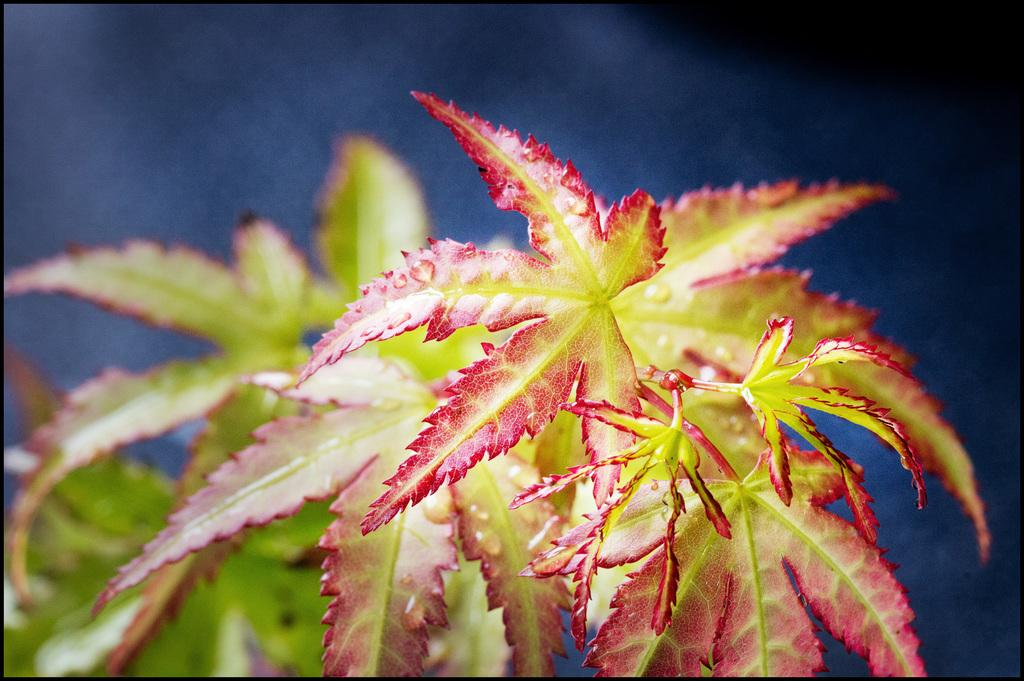What type of vegetation can be seen in the image? There are leaves in the image. What colors are present on the leaves? The leaves have red and green colors. What color is the background of the image? The background of the image is blue. What type of rice is being harvested in the image? There is no rice present in the image; it features leaves with red and green colors against a blue background. What year is depicted in the image? The image does not depict a specific year; it only shows leaves with red and green colors against a blue background. 